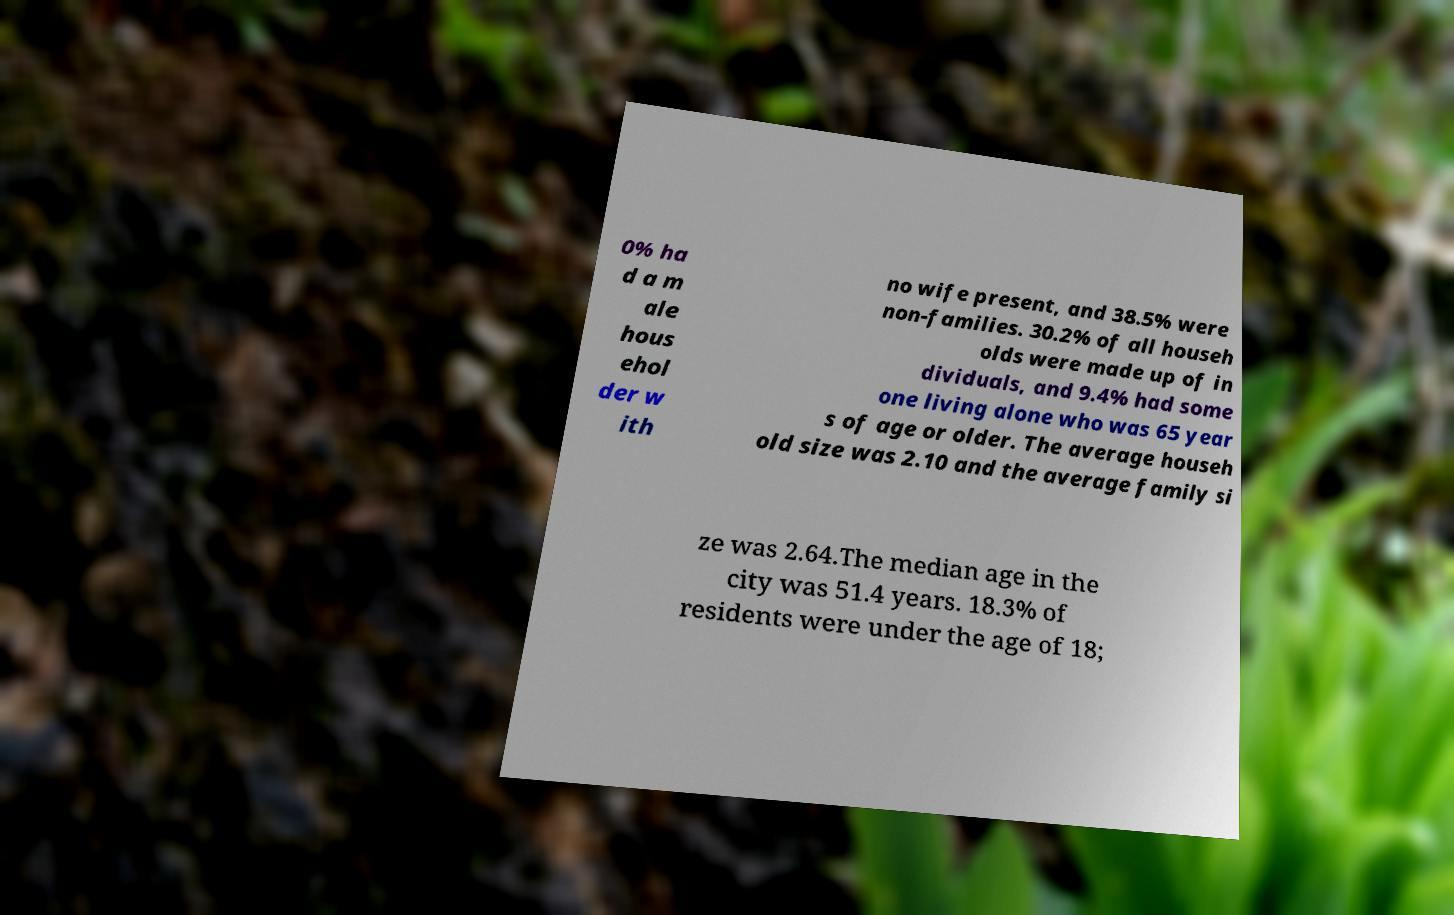I need the written content from this picture converted into text. Can you do that? 0% ha d a m ale hous ehol der w ith no wife present, and 38.5% were non-families. 30.2% of all househ olds were made up of in dividuals, and 9.4% had some one living alone who was 65 year s of age or older. The average househ old size was 2.10 and the average family si ze was 2.64.The median age in the city was 51.4 years. 18.3% of residents were under the age of 18; 